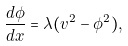<formula> <loc_0><loc_0><loc_500><loc_500>\frac { d \phi } { d x } = \lambda ( v ^ { 2 } - \phi ^ { 2 } ) ,</formula> 